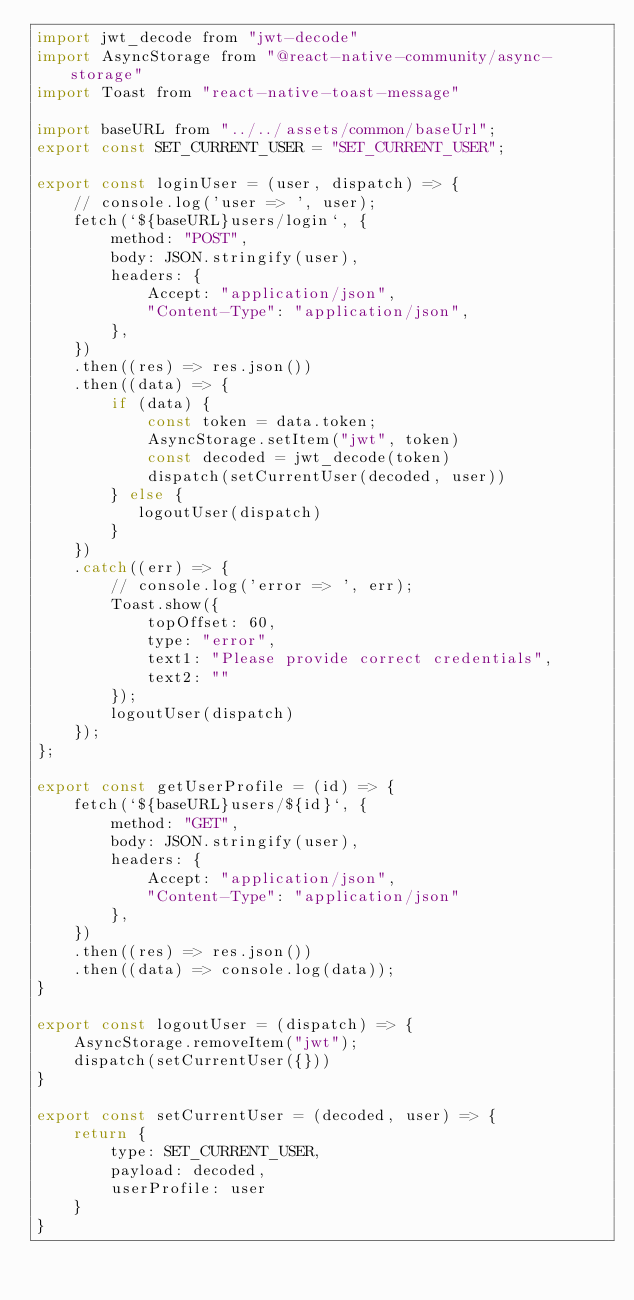<code> <loc_0><loc_0><loc_500><loc_500><_JavaScript_>import jwt_decode from "jwt-decode"
import AsyncStorage from "@react-native-community/async-storage"
import Toast from "react-native-toast-message"

import baseURL from "../../assets/common/baseUrl";
export const SET_CURRENT_USER = "SET_CURRENT_USER";

export const loginUser = (user, dispatch) => {
    // console.log('user => ', user);
    fetch(`${baseURL}users/login`, {
        method: "POST",
        body: JSON.stringify(user),
        headers: {
            Accept: "application/json",
            "Content-Type": "application/json",
        },
    })
    .then((res) => res.json())
    .then((data) => {
        if (data) {
            const token = data.token;
            AsyncStorage.setItem("jwt", token)
            const decoded = jwt_decode(token)
            dispatch(setCurrentUser(decoded, user))
        } else {
           logoutUser(dispatch)
        }
    })
    .catch((err) => {
        // console.log('error => ', err);
        Toast.show({
            topOffset: 60,
            type: "error",
            text1: "Please provide correct credentials",
            text2: ""
        });
        logoutUser(dispatch)
    });
};

export const getUserProfile = (id) => {
    fetch(`${baseURL}users/${id}`, {
        method: "GET",
        body: JSON.stringify(user),
        headers: {
            Accept: "application/json",
            "Content-Type": "application/json"
        },
    })
    .then((res) => res.json())
    .then((data) => console.log(data));
}

export const logoutUser = (dispatch) => {
    AsyncStorage.removeItem("jwt");
    dispatch(setCurrentUser({}))
}

export const setCurrentUser = (decoded, user) => {
    return {
        type: SET_CURRENT_USER,
        payload: decoded,
        userProfile: user
    }
}</code> 